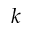<formula> <loc_0><loc_0><loc_500><loc_500>k</formula> 